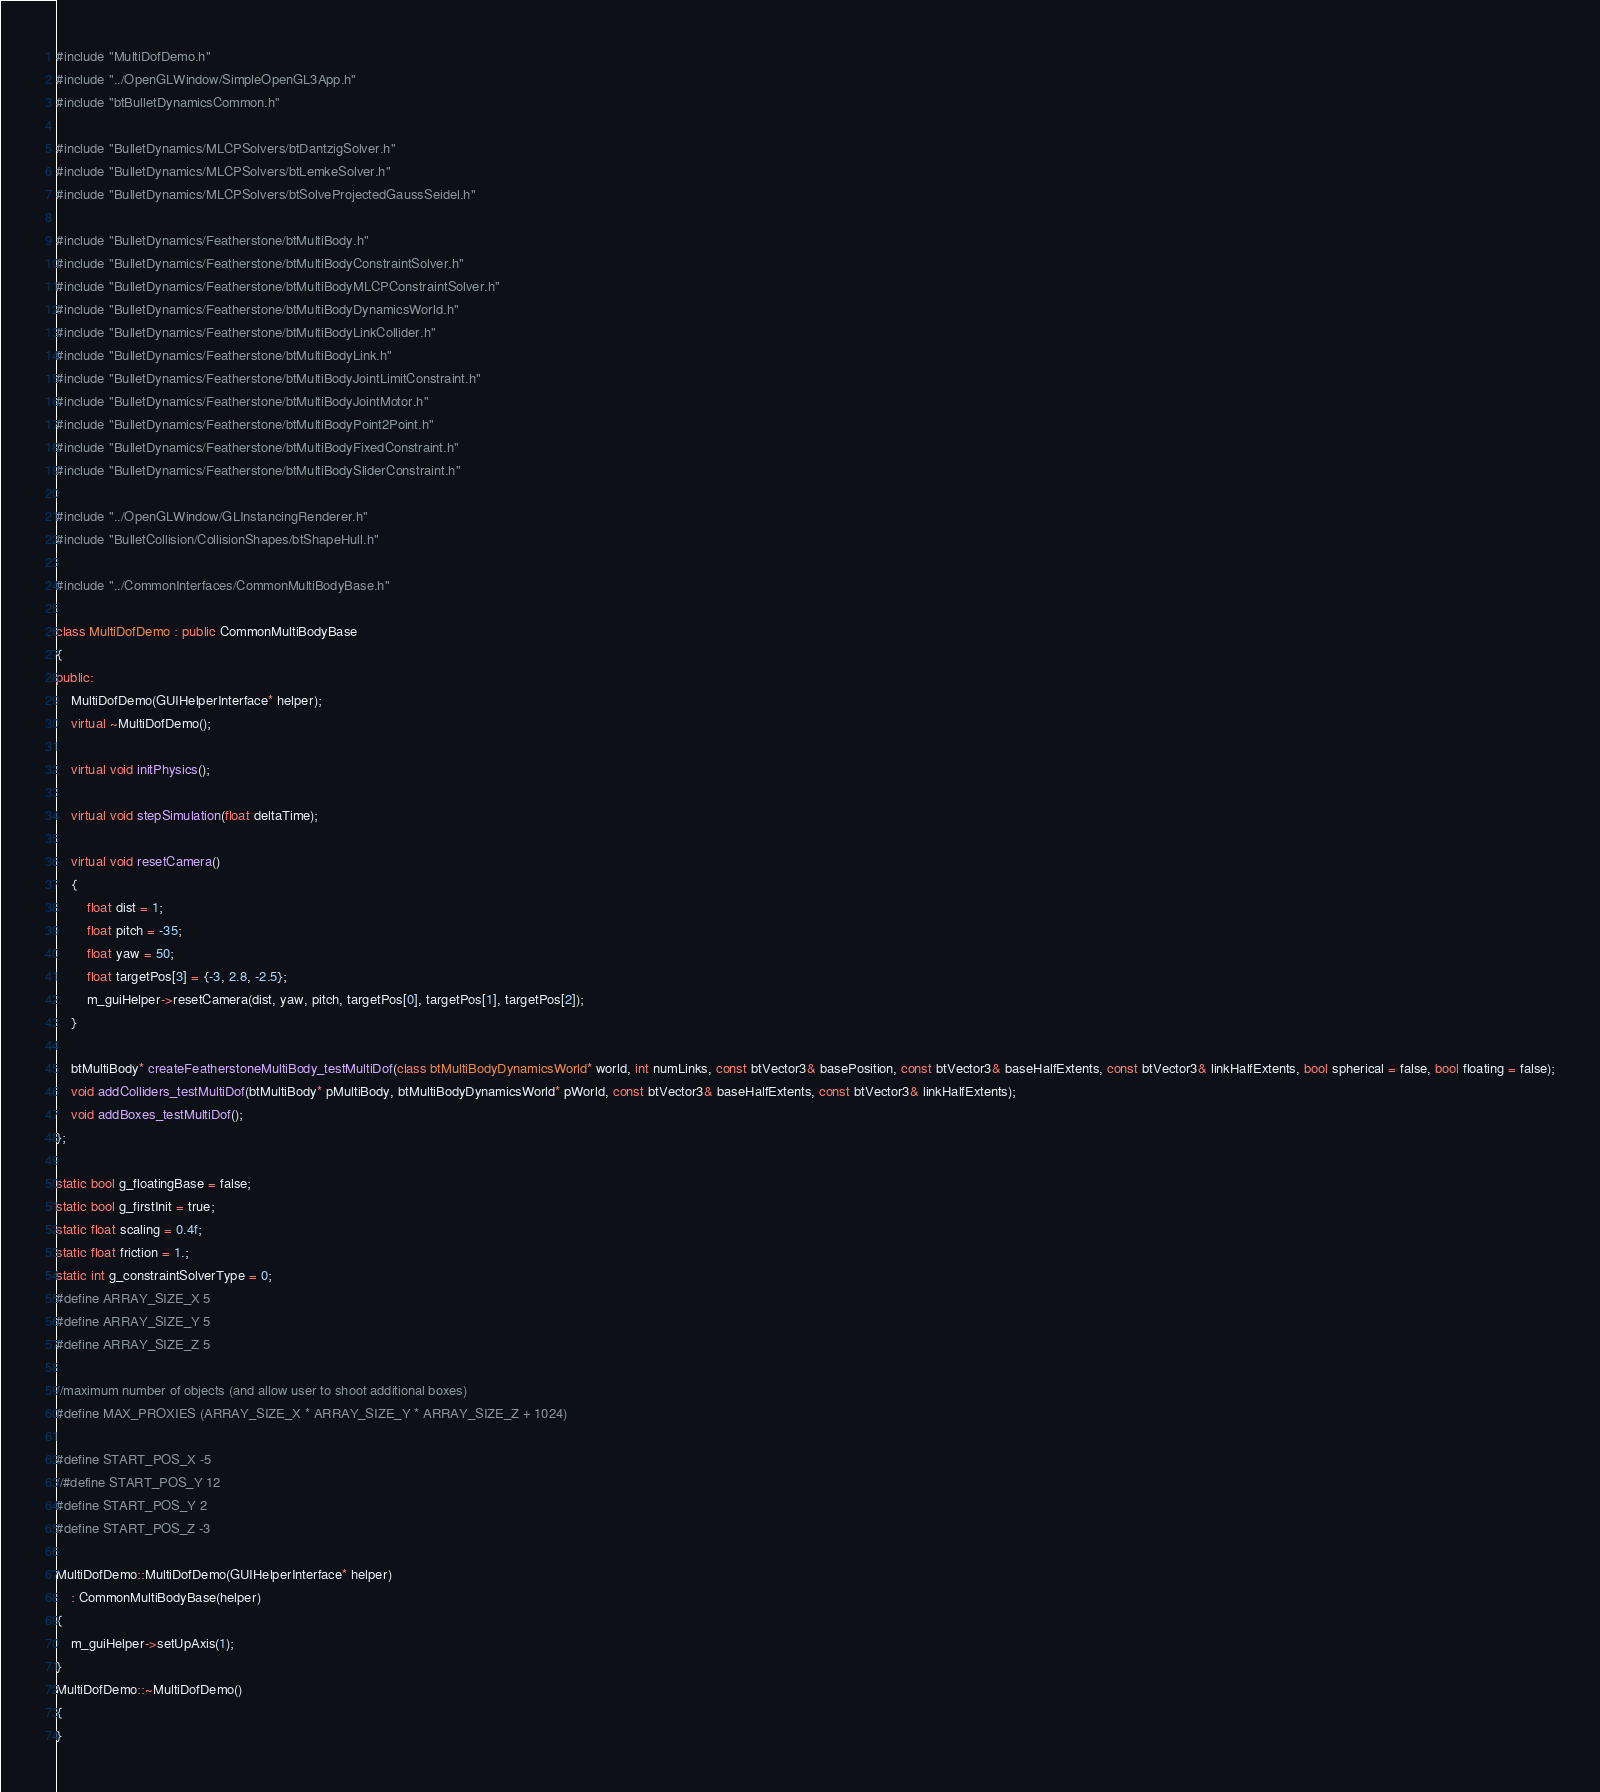<code> <loc_0><loc_0><loc_500><loc_500><_C++_>#include "MultiDofDemo.h"
#include "../OpenGLWindow/SimpleOpenGL3App.h"
#include "btBulletDynamicsCommon.h"

#include "BulletDynamics/MLCPSolvers/btDantzigSolver.h"
#include "BulletDynamics/MLCPSolvers/btLemkeSolver.h"
#include "BulletDynamics/MLCPSolvers/btSolveProjectedGaussSeidel.h"

#include "BulletDynamics/Featherstone/btMultiBody.h"
#include "BulletDynamics/Featherstone/btMultiBodyConstraintSolver.h"
#include "BulletDynamics/Featherstone/btMultiBodyMLCPConstraintSolver.h"
#include "BulletDynamics/Featherstone/btMultiBodyDynamicsWorld.h"
#include "BulletDynamics/Featherstone/btMultiBodyLinkCollider.h"
#include "BulletDynamics/Featherstone/btMultiBodyLink.h"
#include "BulletDynamics/Featherstone/btMultiBodyJointLimitConstraint.h"
#include "BulletDynamics/Featherstone/btMultiBodyJointMotor.h"
#include "BulletDynamics/Featherstone/btMultiBodyPoint2Point.h"
#include "BulletDynamics/Featherstone/btMultiBodyFixedConstraint.h"
#include "BulletDynamics/Featherstone/btMultiBodySliderConstraint.h"

#include "../OpenGLWindow/GLInstancingRenderer.h"
#include "BulletCollision/CollisionShapes/btShapeHull.h"

#include "../CommonInterfaces/CommonMultiBodyBase.h"

class MultiDofDemo : public CommonMultiBodyBase
{
public:
	MultiDofDemo(GUIHelperInterface* helper);
	virtual ~MultiDofDemo();

	virtual void initPhysics();

	virtual void stepSimulation(float deltaTime);

	virtual void resetCamera()
	{
		float dist = 1;
		float pitch = -35;
		float yaw = 50;
		float targetPos[3] = {-3, 2.8, -2.5};
		m_guiHelper->resetCamera(dist, yaw, pitch, targetPos[0], targetPos[1], targetPos[2]);
	}

	btMultiBody* createFeatherstoneMultiBody_testMultiDof(class btMultiBodyDynamicsWorld* world, int numLinks, const btVector3& basePosition, const btVector3& baseHalfExtents, const btVector3& linkHalfExtents, bool spherical = false, bool floating = false);
	void addColliders_testMultiDof(btMultiBody* pMultiBody, btMultiBodyDynamicsWorld* pWorld, const btVector3& baseHalfExtents, const btVector3& linkHalfExtents);
	void addBoxes_testMultiDof();
};

static bool g_floatingBase = false;
static bool g_firstInit = true;
static float scaling = 0.4f;
static float friction = 1.;
static int g_constraintSolverType = 0;
#define ARRAY_SIZE_X 5
#define ARRAY_SIZE_Y 5
#define ARRAY_SIZE_Z 5

//maximum number of objects (and allow user to shoot additional boxes)
#define MAX_PROXIES (ARRAY_SIZE_X * ARRAY_SIZE_Y * ARRAY_SIZE_Z + 1024)

#define START_POS_X -5
//#define START_POS_Y 12
#define START_POS_Y 2
#define START_POS_Z -3

MultiDofDemo::MultiDofDemo(GUIHelperInterface* helper)
	: CommonMultiBodyBase(helper)
{
	m_guiHelper->setUpAxis(1);
}
MultiDofDemo::~MultiDofDemo()
{
}
</code> 